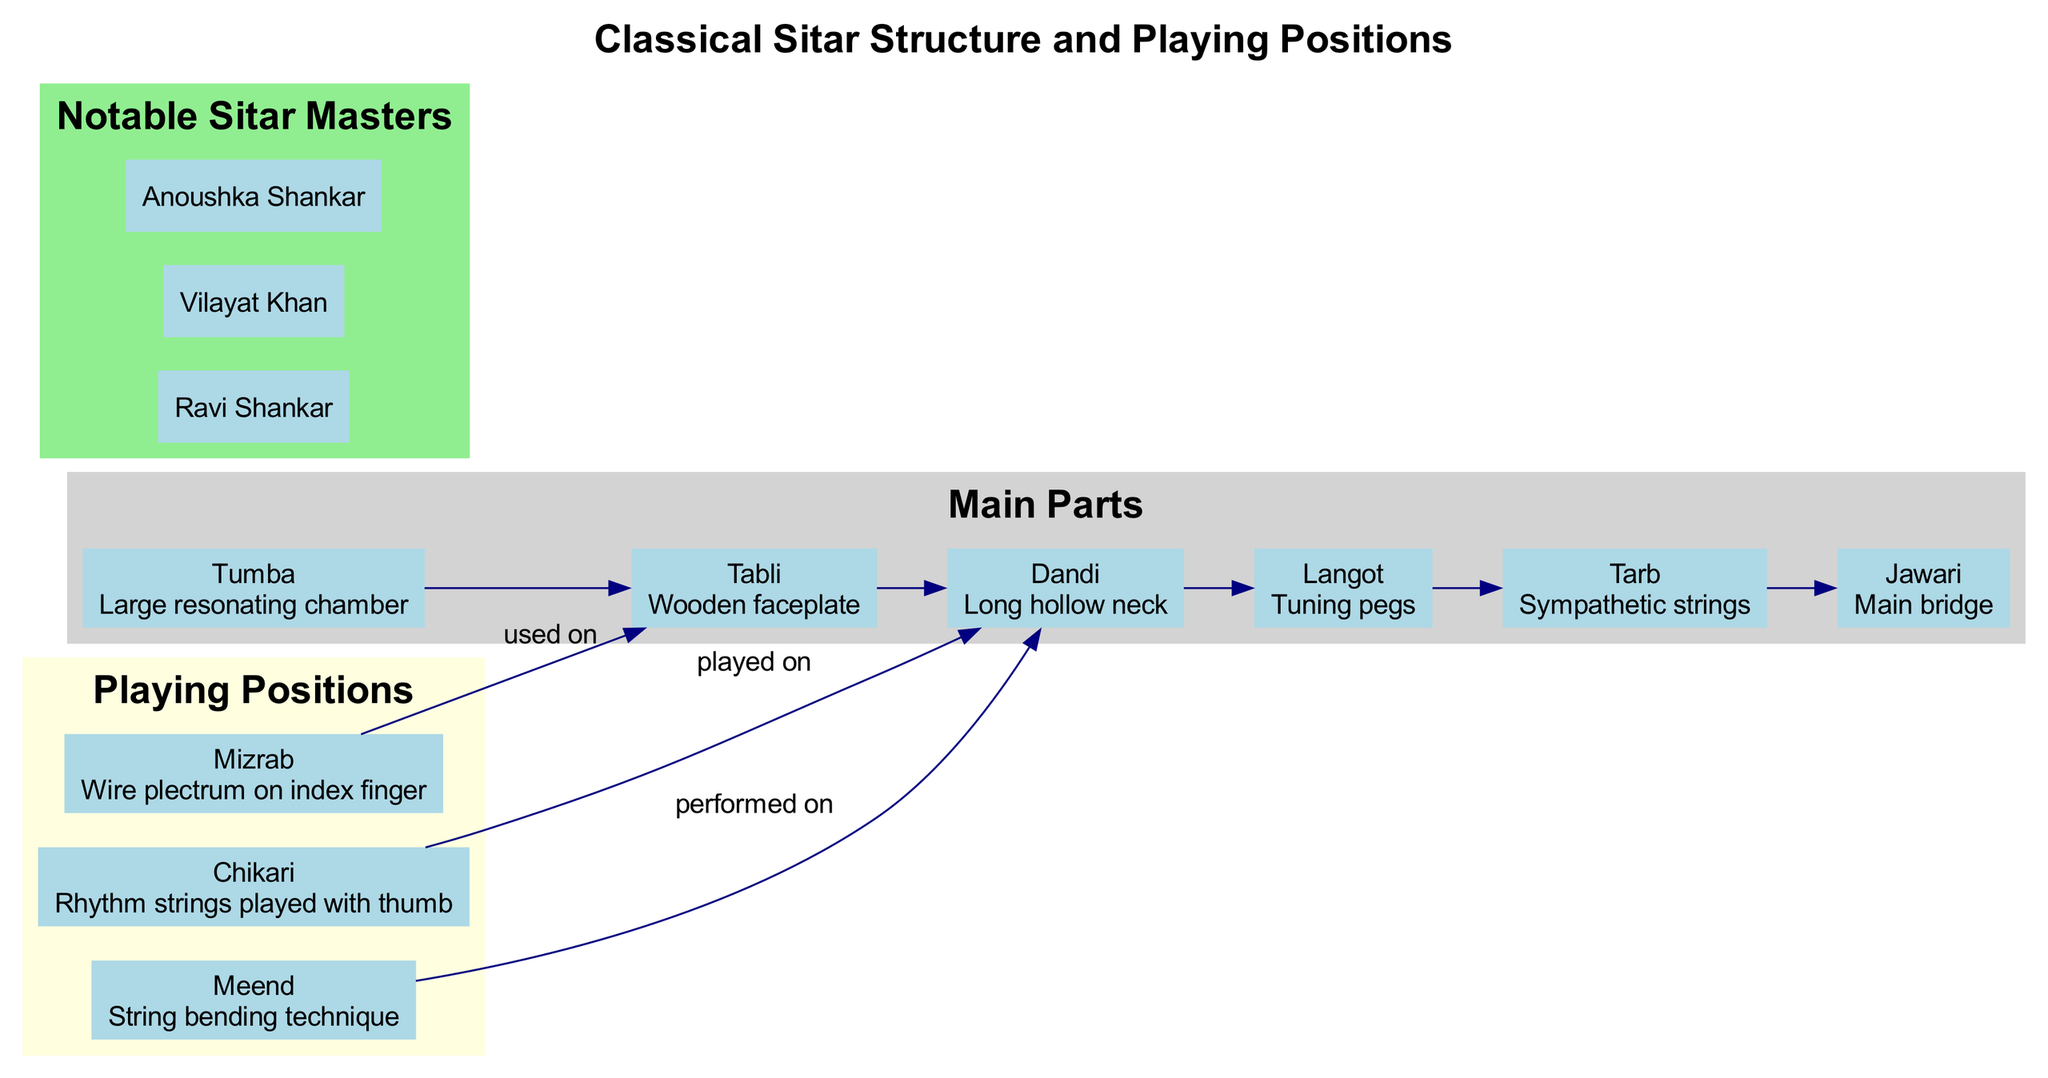What's the main resonating chamber of the sitar? The main resonating chamber is labeled as "Tumba" in the diagram, and its description indicates that it serves a crucial role in sound amplification.
Answer: Tumba How many main parts does the sitar have? By counting the nodes in the "Main Parts" section, there are six labeled nodes representing different parts of the sitar.
Answer: 6 Which playing position is associated with the string bending technique? The "Meend" node clearly indicates that this playing position involves bending the string, as described in its label within the "Playing Positions" section.
Answer: Meend What is the purpose of the "Jawari" in the sitar? The "Jawari" is described as the "Main bridge," which means it plays an integral role in sound production and string vibration. It connects the strings to the body of the sitar.
Answer: Main bridge Which sitar master is prominently known for their contributions to classical sitar music? Among the notable sitar masters listed, "Ravi Shankar" is widely recognized for his international influence and contributions to popularizing the sitar.
Answer: Ravi Shankar Which part of the sitar is used for rhythm string playing? The "Chikari," as described in its label, is intended for playing rhythm strings, indicating its functional role in the performance.
Answer: Chikari What connects the "Dandi" to the playing positions? The "Dandi" is linked to both "Chikari" and "Meend," indicating that both playing techniques are performed on this specific part of the sitar.
Answer: Chikari, Meend Who is associated with the sympathetic strings? The diagram labels "Tarb" as the part of the sitar associated with sympathetic strings, explaining its function in enriching the instrument's sound.
Answer: Tarb Which is the long hollow neck section of the sitar called? The diagram clearly labels the long hollow neck of the sitar as "Dandi," which describes its shape and function.
Answer: Dandi 